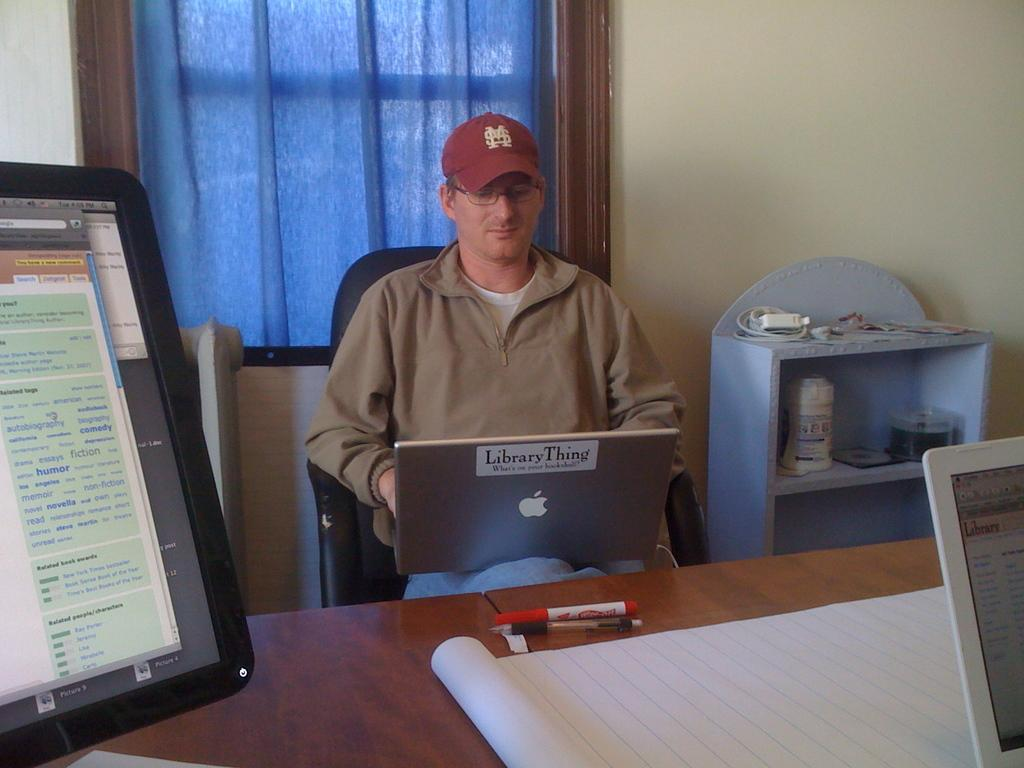<image>
Summarize the visual content of the image. A man works on a laptop that has a "Library Thing" sticker stuck to the back of the screen. 